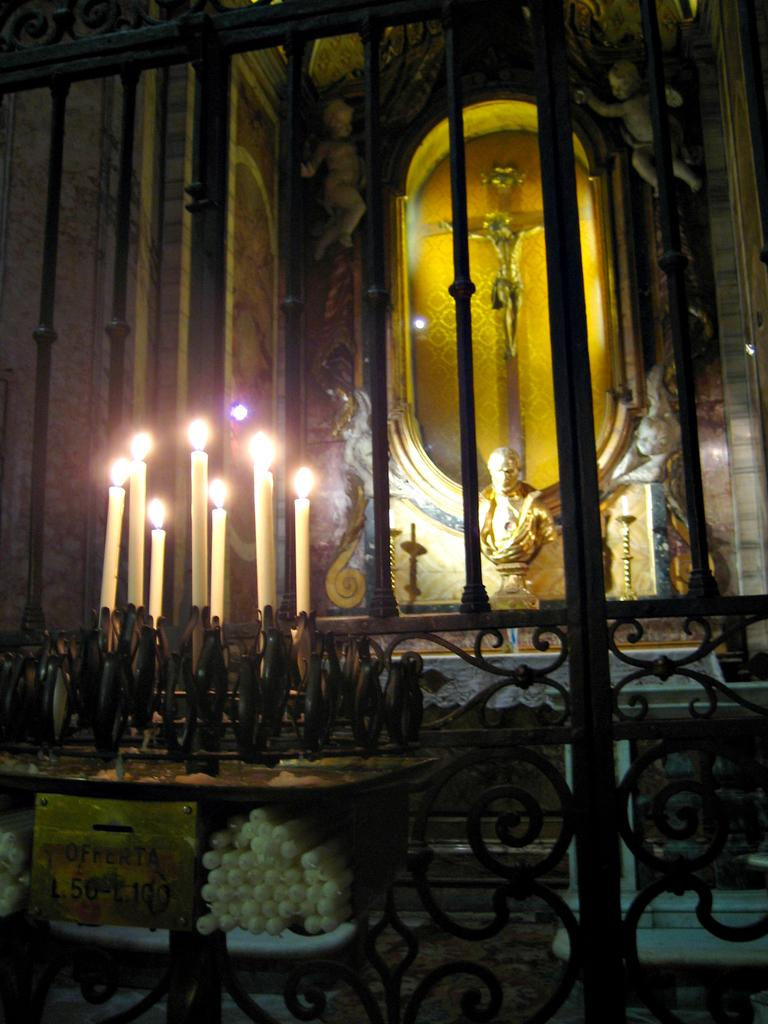What objects can be seen in the image? There are candles in the image. Where are the candles placed? The candles are placed in front of statues. Can you describe the statue in the background of the image? There is a statue of Jesus Christ on a cross in the background of the image. What type of appliance can be seen in the image? There is no appliance present in the image. How many pests can be seen crawling on the statues in the image? There are no pests visible in the image; it features candles and statues. 